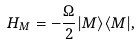<formula> <loc_0><loc_0><loc_500><loc_500>H _ { M } = - \frac { \Omega } { 2 } | M \rangle \langle M | ,</formula> 